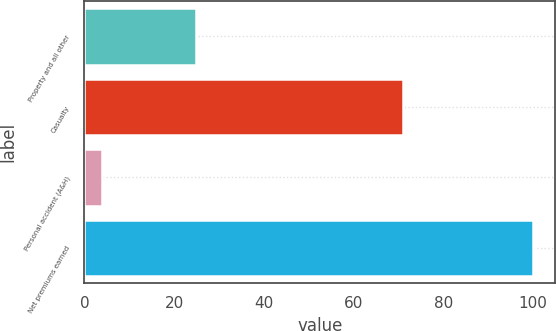Convert chart to OTSL. <chart><loc_0><loc_0><loc_500><loc_500><bar_chart><fcel>Property and all other<fcel>Casualty<fcel>Personal accident (A&H)<fcel>Net premiums earned<nl><fcel>25<fcel>71<fcel>4<fcel>100<nl></chart> 